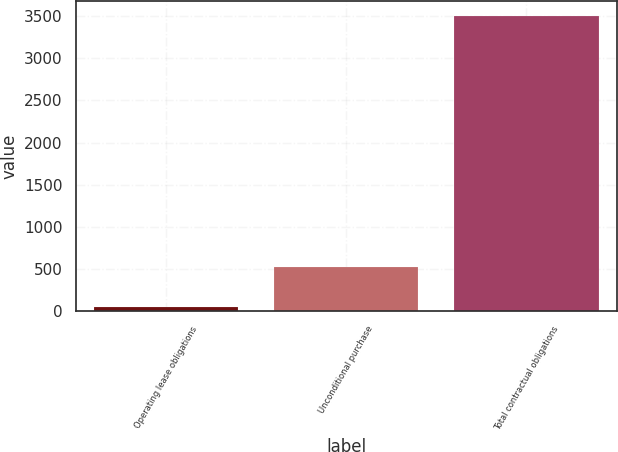Convert chart to OTSL. <chart><loc_0><loc_0><loc_500><loc_500><bar_chart><fcel>Operating lease obligations<fcel>Unconditional purchase<fcel>Total contractual obligations<nl><fcel>49.6<fcel>530.1<fcel>3497.5<nl></chart> 